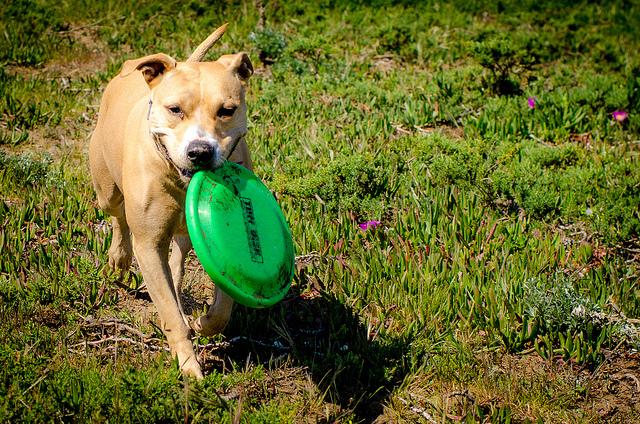Could this be on a beach?
Be succinct. No. Is this photo appear to be in the winter?
Keep it brief. No. Is the dog playing?
Concise answer only. Yes. What is the dog holding?
Quick response, please. Frisbee. How is the dog's tail?
Be succinct. Wagging. What colors is the dog's toy?
Answer briefly. Green. 